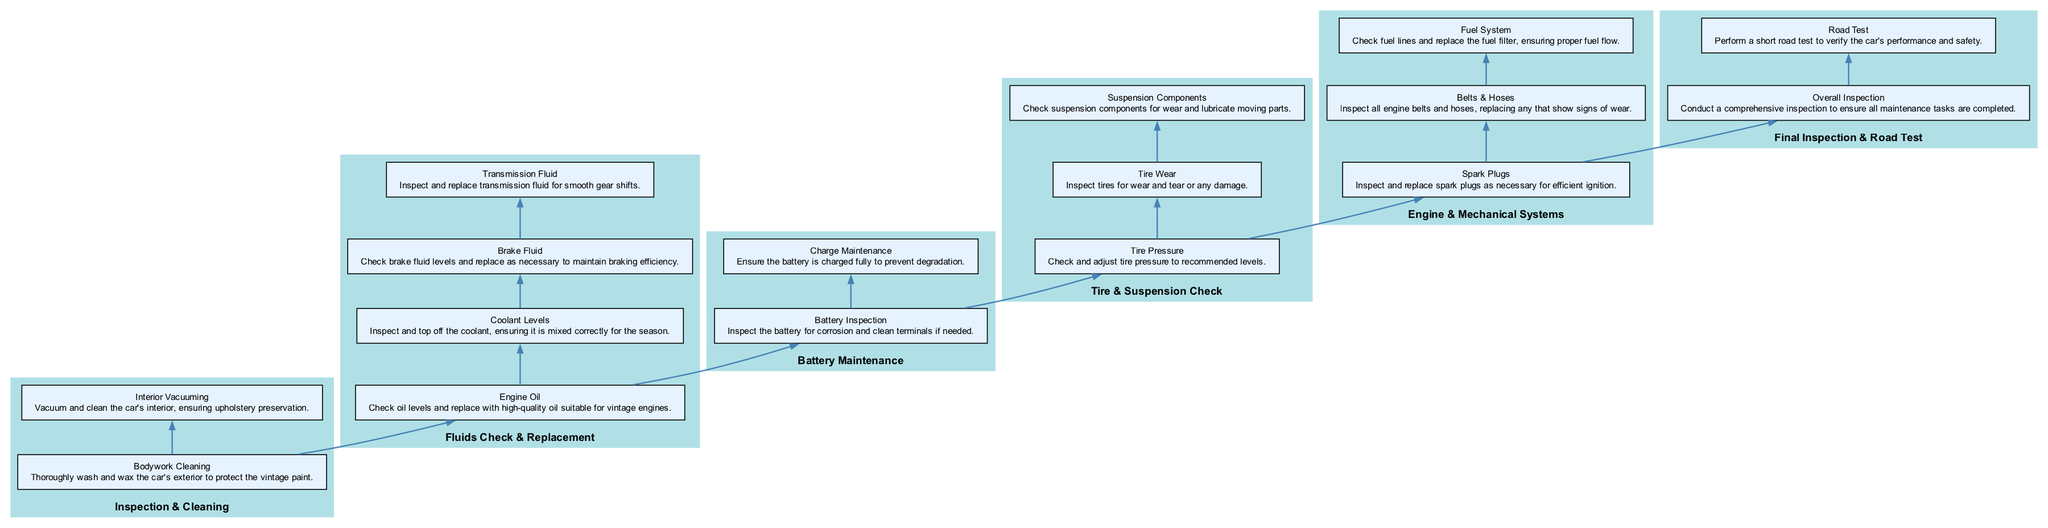What is the first step in the maintenance routine? The maintenance routine begins with "Inspection & Cleaning," which is the first element in the flow chart.
Answer: Inspection & Cleaning How many steps are there in the "Fluids Check & Replacement" section? In the "Fluids Check & Replacement" section, there are four steps, which can be counted directly from the diagram.
Answer: 4 What follows the "Tire & Suspension Check" in the flow chart? Following the "Tire & Suspension Check," the next element listed in the flow chart is "Engine & Mechanical Systems."
Answer: Engine & Mechanical Systems Which step checks battery terminals for corrosion? The step labeled "Battery Inspection" specifically addresses checking battery terminals for corrosion.
Answer: Battery Inspection What is the purpose of the "Final Inspection & Road Test" step? The "Final Inspection & Road Test" is to conduct an overall inspection and perform a road test to ensure the car's performance and safety, as described in the diagram.
Answer: Overall Inspection How many main sections are there in the maintenance routine? There are six main sections in the maintenance routine, which can be identified by counting each element in the flow chart.
Answer: 6 Which step is focused on tire condition? The step that focuses on tire condition is "Tire Wear," which inspects tires for wear and tear or any damage.
Answer: Tire Wear What must be done first before the "Road Test"? Before the "Road Test," the "Overall Inspection" must be completed, as listed directly above it in the flow chart.
Answer: Overall Inspection What type of maintenance is done on the "Fuel System"? The "Fuel System" maintenance involves checking fuel lines and replacing the fuel filter to ensure proper fuel flow.
Answer: Check fuel lines and replace fuel filter What should be checked for wear along with spark plugs? Along with spark plugs, "Belts & Hoses" should also be inspected for wear in the engine and mechanical systems section.
Answer: Belts & Hoses 